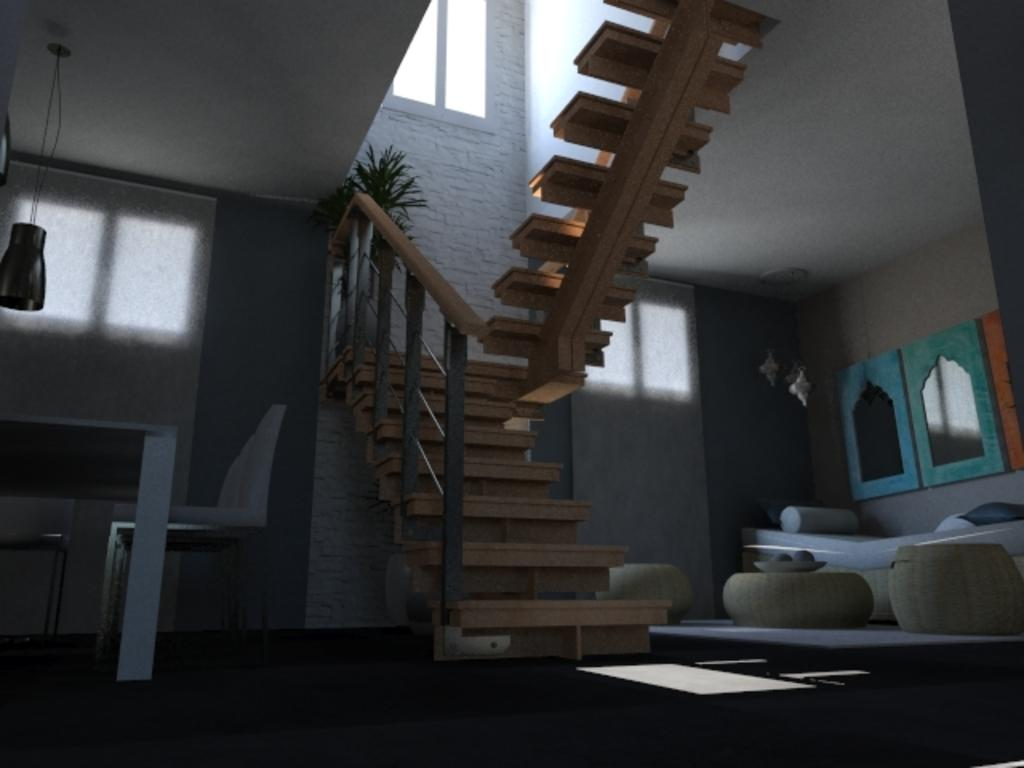What type of room is shown in the image? The image shows the inside of a house. What type of furniture is present in the room? There is a couch, chairs, side tables, and a table in the image. What type of decorative items can be seen in the room? There are star cases in the image. What type of plant is present in the room? There is a potted plant in the image. What type of hand-crafted locket can be seen hanging from the potted plant in the image? There is no locket present in the image, and the potted plant is not described as having any decorations or accessories. 